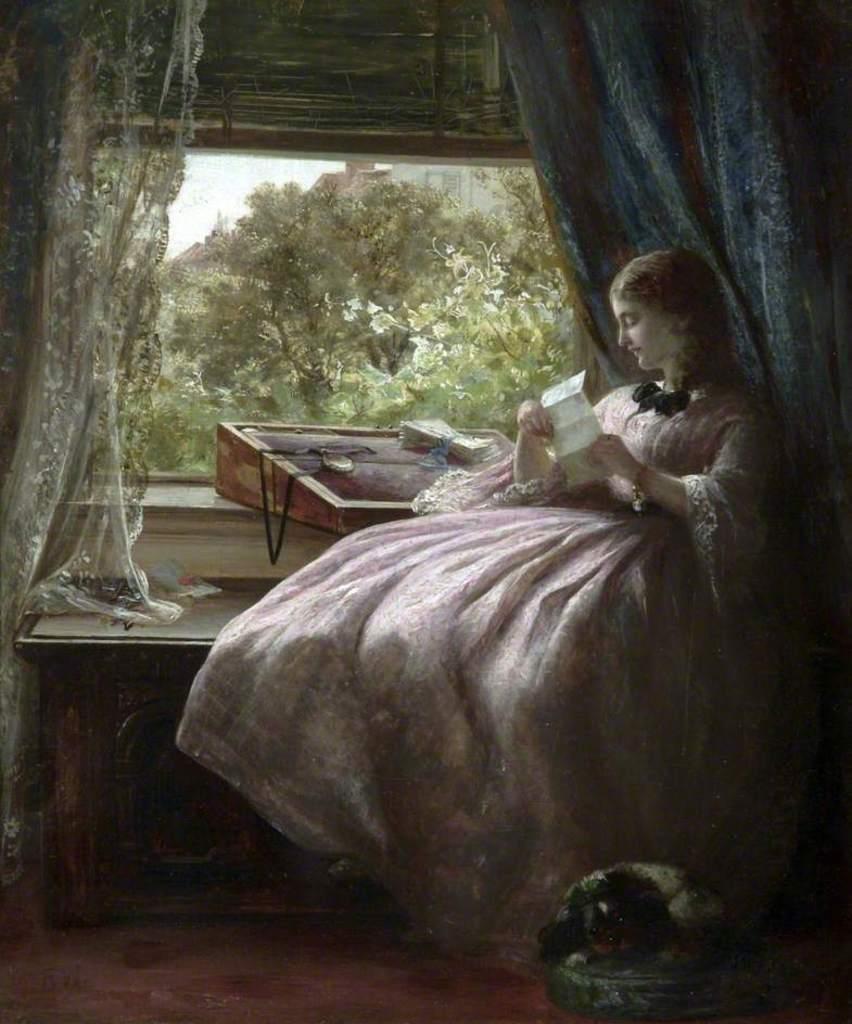Can you describe this image briefly? In this picture I can see there is a woman sitting on the bench and she is holding a paper, there is a wooden plank in front of her, there is an object placed on the floor and there is a window in the backdrop and there are few trees and building visible from the window and the sky is clear. 